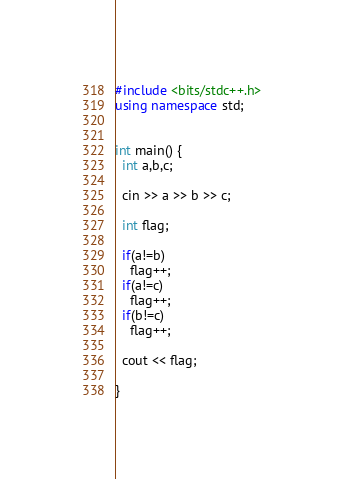<code> <loc_0><loc_0><loc_500><loc_500><_C++_>#include <bits/stdc++.h>
using namespace std;
  

int main() {
  int a,b,c;
  
  cin >> a >> b >> c;
  
  int flag;
  
  if(a!=b)
    flag++;
  if(a!=c)
    flag++;
  if(b!=c)
    flag++;
  
  cout << flag;
  
}</code> 